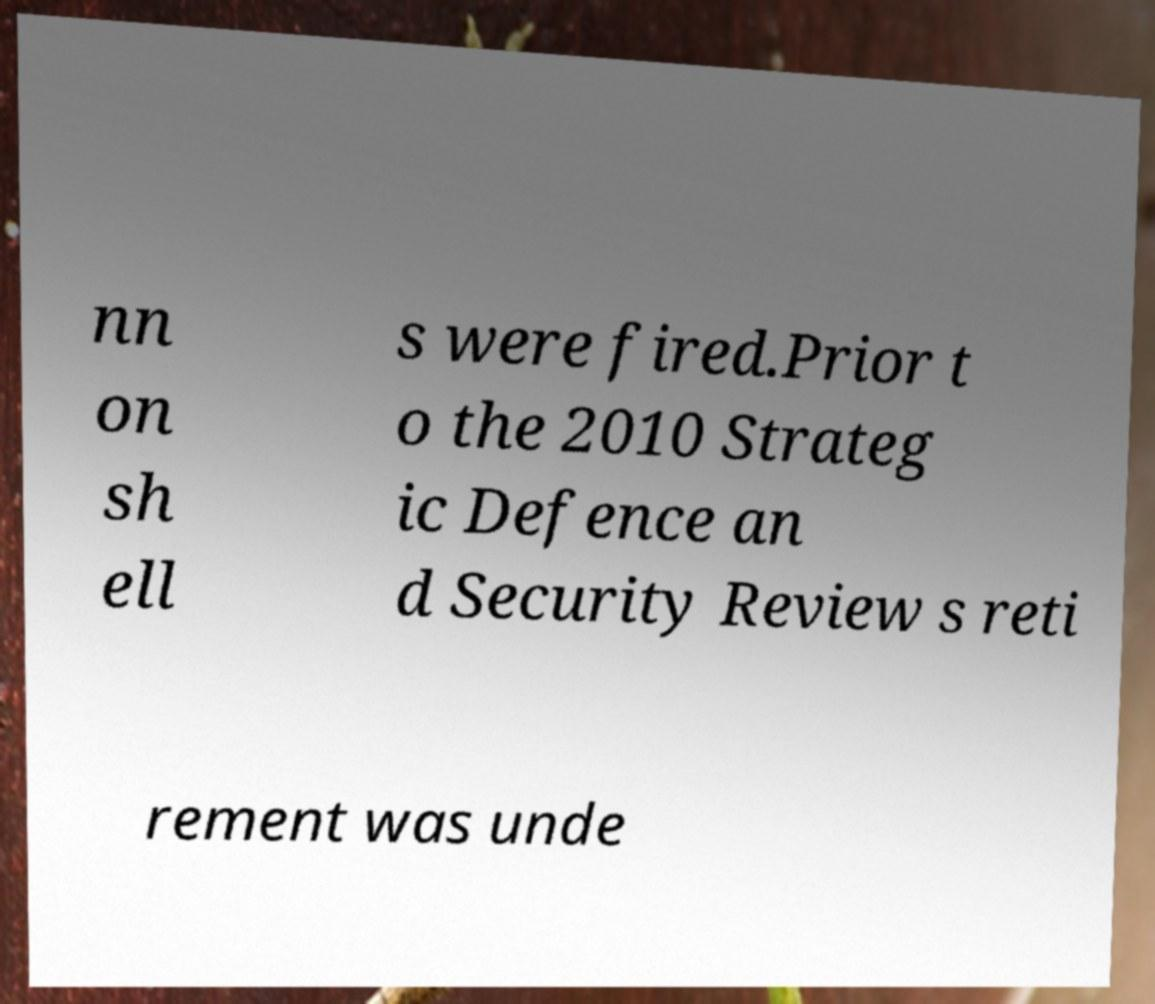Could you assist in decoding the text presented in this image and type it out clearly? nn on sh ell s were fired.Prior t o the 2010 Strateg ic Defence an d Security Review s reti rement was unde 